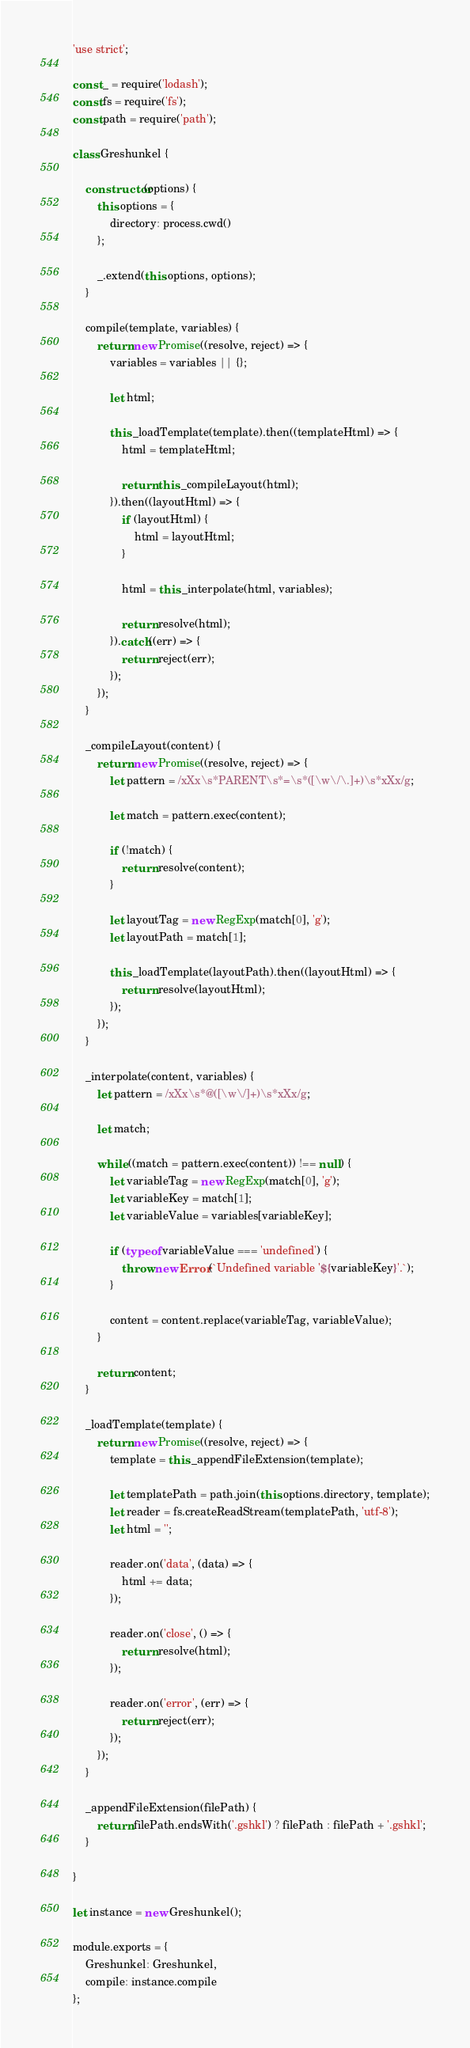Convert code to text. <code><loc_0><loc_0><loc_500><loc_500><_JavaScript_>'use strict';

const _ = require('lodash');
const fs = require('fs');
const path = require('path');

class Greshunkel {

    constructor(options) {
        this.options = {
            directory: process.cwd()
        };

        _.extend(this.options, options);
    }

    compile(template, variables) {
        return new Promise((resolve, reject) => {
            variables = variables || {};

            let html;

            this._loadTemplate(template).then((templateHtml) => {
                html = templateHtml;

                return this._compileLayout(html);
            }).then((layoutHtml) => {
                if (layoutHtml) {
                    html = layoutHtml;
                }

                html = this._interpolate(html, variables);

                return resolve(html);
            }).catch((err) => {
                return reject(err);
            });
        });
    }

    _compileLayout(content) {
        return new Promise((resolve, reject) => {
            let pattern = /xXx\s*PARENT\s*=\s*([\w\/\.]+)\s*xXx/g;

            let match = pattern.exec(content);

            if (!match) {
                return resolve(content);
            }

            let layoutTag = new RegExp(match[0], 'g');
            let layoutPath = match[1];

            this._loadTemplate(layoutPath).then((layoutHtml) => {
                return resolve(layoutHtml);
            });
        });
    }

    _interpolate(content, variables) {
        let pattern = /xXx\s*@([\w\/]+)\s*xXx/g;

        let match;

        while ((match = pattern.exec(content)) !== null) {
            let variableTag = new RegExp(match[0], 'g');
            let variableKey = match[1];
            let variableValue = variables[variableKey];

            if (typeof variableValue === 'undefined') {
                throw new Error(`Undefined variable '${variableKey}'.`);
            }

            content = content.replace(variableTag, variableValue);
        }

        return content;
    }

    _loadTemplate(template) {
        return new Promise((resolve, reject) => {
            template = this._appendFileExtension(template);

            let templatePath = path.join(this.options.directory, template);
            let reader = fs.createReadStream(templatePath, 'utf-8');
            let html = '';

            reader.on('data', (data) => {
                html += data;
            });

            reader.on('close', () => {
                return resolve(html);
            });

            reader.on('error', (err) => {
                return reject(err);
            });
        });
    }

    _appendFileExtension(filePath) {
        return filePath.endsWith('.gshkl') ? filePath : filePath + '.gshkl';
    }

}

let instance = new Greshunkel();

module.exports = {
    Greshunkel: Greshunkel,
    compile: instance.compile
};
</code> 